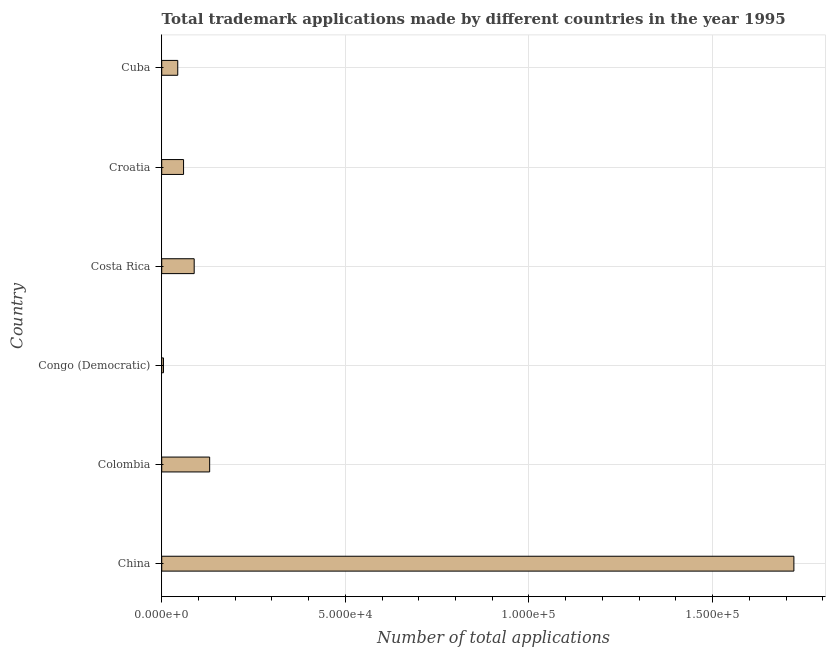Does the graph contain grids?
Your response must be concise. Yes. What is the title of the graph?
Provide a short and direct response. Total trademark applications made by different countries in the year 1995. What is the label or title of the X-axis?
Offer a very short reply. Number of total applications. What is the label or title of the Y-axis?
Your answer should be compact. Country. What is the number of trademark applications in Congo (Democratic)?
Ensure brevity in your answer.  478. Across all countries, what is the maximum number of trademark applications?
Your response must be concise. 1.72e+05. Across all countries, what is the minimum number of trademark applications?
Your answer should be compact. 478. In which country was the number of trademark applications minimum?
Keep it short and to the point. Congo (Democratic). What is the sum of the number of trademark applications?
Your response must be concise. 2.05e+05. What is the difference between the number of trademark applications in China and Cuba?
Offer a very short reply. 1.68e+05. What is the average number of trademark applications per country?
Keep it short and to the point. 3.41e+04. What is the median number of trademark applications?
Ensure brevity in your answer.  7397.5. What is the ratio of the number of trademark applications in Colombia to that in Congo (Democratic)?
Provide a short and direct response. 27.31. Is the number of trademark applications in Colombia less than that in Congo (Democratic)?
Provide a short and direct response. No. What is the difference between the highest and the second highest number of trademark applications?
Keep it short and to the point. 1.59e+05. Is the sum of the number of trademark applications in China and Congo (Democratic) greater than the maximum number of trademark applications across all countries?
Your answer should be very brief. Yes. What is the difference between the highest and the lowest number of trademark applications?
Your answer should be very brief. 1.72e+05. How many bars are there?
Provide a succinct answer. 6. Are all the bars in the graph horizontal?
Offer a very short reply. Yes. Are the values on the major ticks of X-axis written in scientific E-notation?
Your answer should be very brief. Yes. What is the Number of total applications in China?
Your response must be concise. 1.72e+05. What is the Number of total applications in Colombia?
Offer a terse response. 1.31e+04. What is the Number of total applications in Congo (Democratic)?
Give a very brief answer. 478. What is the Number of total applications in Costa Rica?
Your response must be concise. 8845. What is the Number of total applications of Croatia?
Keep it short and to the point. 5950. What is the Number of total applications in Cuba?
Give a very brief answer. 4367. What is the difference between the Number of total applications in China and Colombia?
Give a very brief answer. 1.59e+05. What is the difference between the Number of total applications in China and Congo (Democratic)?
Keep it short and to the point. 1.72e+05. What is the difference between the Number of total applications in China and Costa Rica?
Make the answer very short. 1.63e+05. What is the difference between the Number of total applications in China and Croatia?
Provide a succinct answer. 1.66e+05. What is the difference between the Number of total applications in China and Cuba?
Provide a succinct answer. 1.68e+05. What is the difference between the Number of total applications in Colombia and Congo (Democratic)?
Provide a succinct answer. 1.26e+04. What is the difference between the Number of total applications in Colombia and Costa Rica?
Make the answer very short. 4209. What is the difference between the Number of total applications in Colombia and Croatia?
Give a very brief answer. 7104. What is the difference between the Number of total applications in Colombia and Cuba?
Your answer should be compact. 8687. What is the difference between the Number of total applications in Congo (Democratic) and Costa Rica?
Your answer should be very brief. -8367. What is the difference between the Number of total applications in Congo (Democratic) and Croatia?
Your answer should be very brief. -5472. What is the difference between the Number of total applications in Congo (Democratic) and Cuba?
Provide a succinct answer. -3889. What is the difference between the Number of total applications in Costa Rica and Croatia?
Provide a succinct answer. 2895. What is the difference between the Number of total applications in Costa Rica and Cuba?
Provide a succinct answer. 4478. What is the difference between the Number of total applications in Croatia and Cuba?
Keep it short and to the point. 1583. What is the ratio of the Number of total applications in China to that in Colombia?
Make the answer very short. 13.19. What is the ratio of the Number of total applications in China to that in Congo (Democratic)?
Keep it short and to the point. 360.14. What is the ratio of the Number of total applications in China to that in Costa Rica?
Keep it short and to the point. 19.46. What is the ratio of the Number of total applications in China to that in Croatia?
Your answer should be very brief. 28.93. What is the ratio of the Number of total applications in China to that in Cuba?
Your response must be concise. 39.42. What is the ratio of the Number of total applications in Colombia to that in Congo (Democratic)?
Provide a succinct answer. 27.31. What is the ratio of the Number of total applications in Colombia to that in Costa Rica?
Give a very brief answer. 1.48. What is the ratio of the Number of total applications in Colombia to that in Croatia?
Ensure brevity in your answer.  2.19. What is the ratio of the Number of total applications in Colombia to that in Cuba?
Make the answer very short. 2.99. What is the ratio of the Number of total applications in Congo (Democratic) to that in Costa Rica?
Your answer should be compact. 0.05. What is the ratio of the Number of total applications in Congo (Democratic) to that in Croatia?
Keep it short and to the point. 0.08. What is the ratio of the Number of total applications in Congo (Democratic) to that in Cuba?
Ensure brevity in your answer.  0.11. What is the ratio of the Number of total applications in Costa Rica to that in Croatia?
Your answer should be very brief. 1.49. What is the ratio of the Number of total applications in Costa Rica to that in Cuba?
Make the answer very short. 2.02. What is the ratio of the Number of total applications in Croatia to that in Cuba?
Offer a terse response. 1.36. 